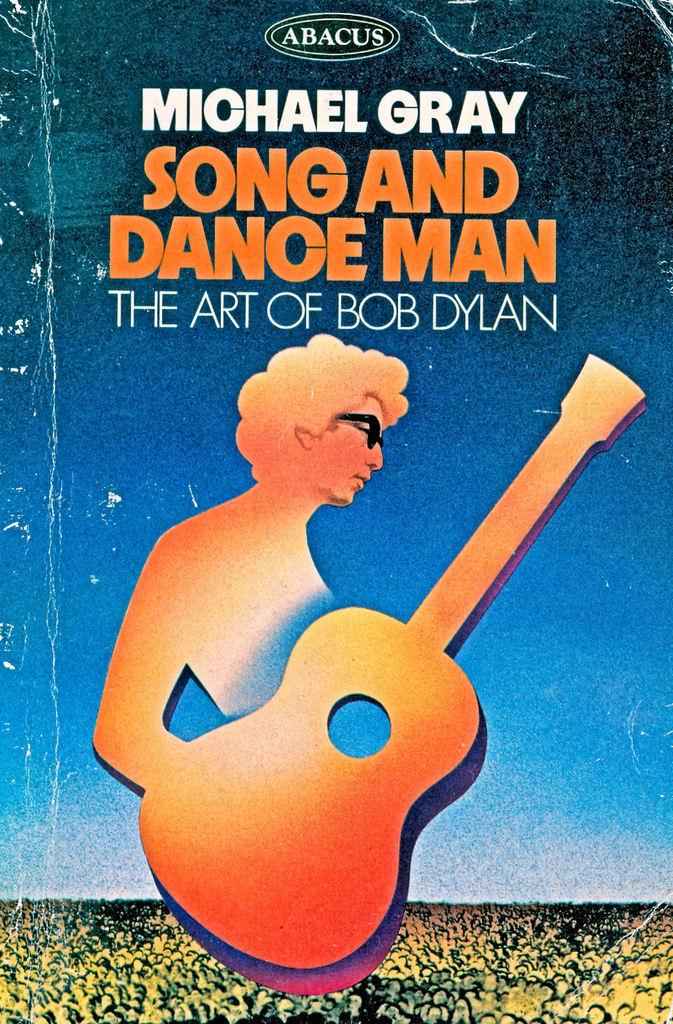<image>
Write a terse but informative summary of the picture. a Michael Gray book wuith an orange image on it 